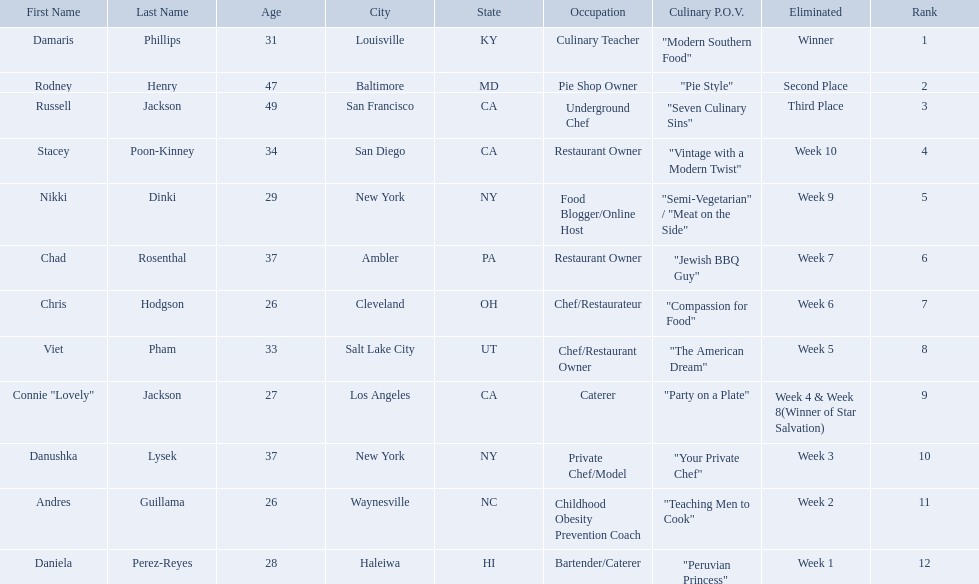Who are the contestants? Damaris Phillips, 31, Rodney Henry, 47, Russell Jackson, 49, Stacey Poon-Kinney, 34, Nikki Dinki, 29, Chad Rosenthal, 37, Chris Hodgson, 26, Viet Pham, 33, Connie "Lovely" Jackson, 27, Danushka Lysek, 37, Andres Guillama, 26, Daniela Perez-Reyes, 28. How old is chris hodgson? 26. Which other contestant has that age? Andres Guillama. Excluding the winner, and second and third place winners, who were the contestants eliminated? Stacey Poon-Kinney, Nikki Dinki, Chad Rosenthal, Chris Hodgson, Viet Pham, Connie "Lovely" Jackson, Danushka Lysek, Andres Guillama, Daniela Perez-Reyes. Of these contestants, who were the last five eliminated before the winner, second, and third place winners were announce? Stacey Poon-Kinney, Nikki Dinki, Chad Rosenthal, Chris Hodgson, Viet Pham. Of these five contestants, was nikki dinki or viet pham eliminated first? Viet Pham. Who where the people in the food network? Damaris Phillips, Rodney Henry, Russell Jackson, Stacey Poon-Kinney, Nikki Dinki, Chad Rosenthal, Chris Hodgson, Viet Pham, Connie "Lovely" Jackson, Danushka Lysek, Andres Guillama, Daniela Perez-Reyes. When was nikki dinki eliminated? Week 9. When was viet pham eliminated? Week 5. Which of these two is earlier? Week 5. Who was eliminated in this week? Viet Pham. Who are the  food network stars? Damaris Phillips, Rodney Henry, Russell Jackson, Stacey Poon-Kinney, Nikki Dinki, Chad Rosenthal, Chris Hodgson, Viet Pham, Connie "Lovely" Jackson, Danushka Lysek, Andres Guillama, Daniela Perez-Reyes. When did nikki dinki get eliminated? Week 9. When did viet pham get eliminated? Week 5. Which week came first? Week 5. Who was it that was eliminated week 5? Viet Pham. Who are all of the contestants? Damaris Phillips, Rodney Henry, Russell Jackson, Stacey Poon-Kinney, Nikki Dinki, Chad Rosenthal, Chris Hodgson, Viet Pham, Connie "Lovely" Jackson, Danushka Lysek, Andres Guillama, Daniela Perez-Reyes. Which culinary p.o.v. is longer than vintage with a modern twist? "Semi-Vegetarian" / "Meat on the Side". Which contestant's p.o.v. is semi-vegetarian/meat on the side? Nikki Dinki. 